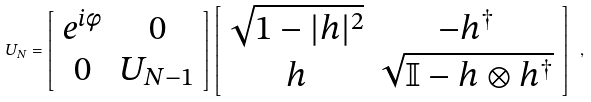Convert formula to latex. <formula><loc_0><loc_0><loc_500><loc_500>U _ { N } = \left [ \begin{array} [ c ] { c c } e ^ { i \phi } & 0 \\ 0 & U _ { N - 1 } \end{array} \right ] \left [ \begin{array} [ c ] { c c } \sqrt { 1 - | h | ^ { 2 } } & - h ^ { \dagger } \\ h & \sqrt { { \mathbb { I } } - h \otimes h ^ { \dagger } } \end{array} \right ] \ ,</formula> 